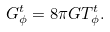<formula> <loc_0><loc_0><loc_500><loc_500>G _ { \phi } ^ { t } = 8 \pi G T _ { \phi } ^ { t } .</formula> 